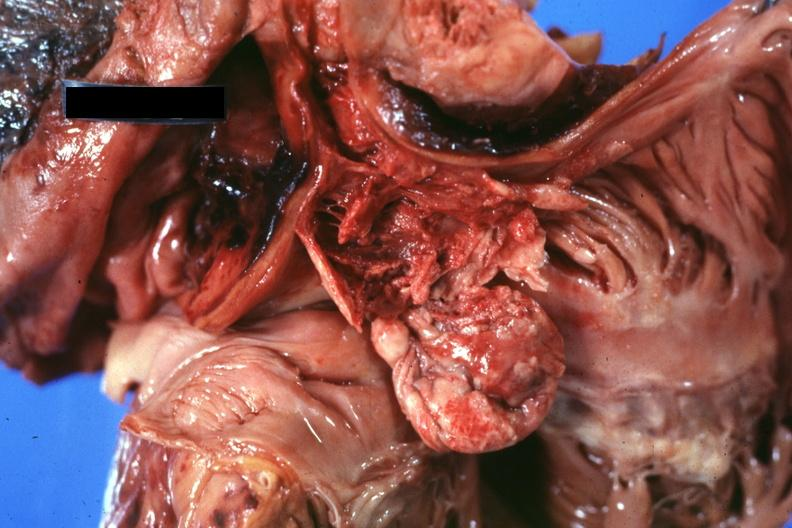what is present?
Answer the question using a single word or phrase. Thymus 